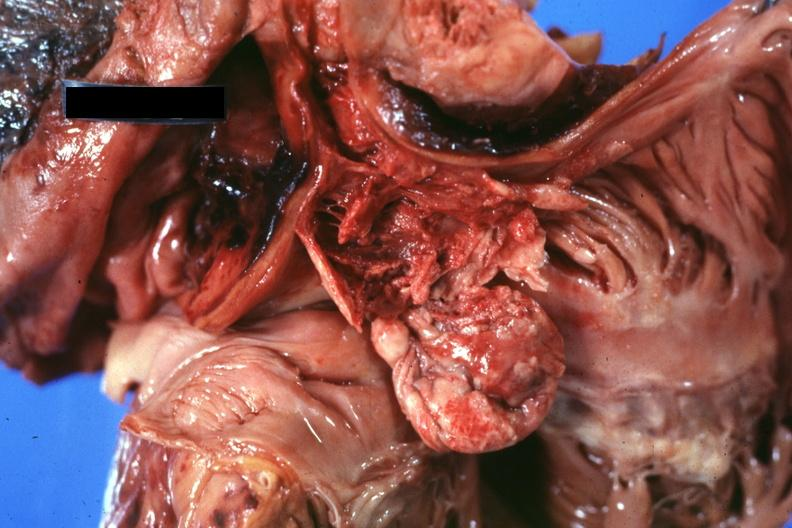what is present?
Answer the question using a single word or phrase. Thymus 